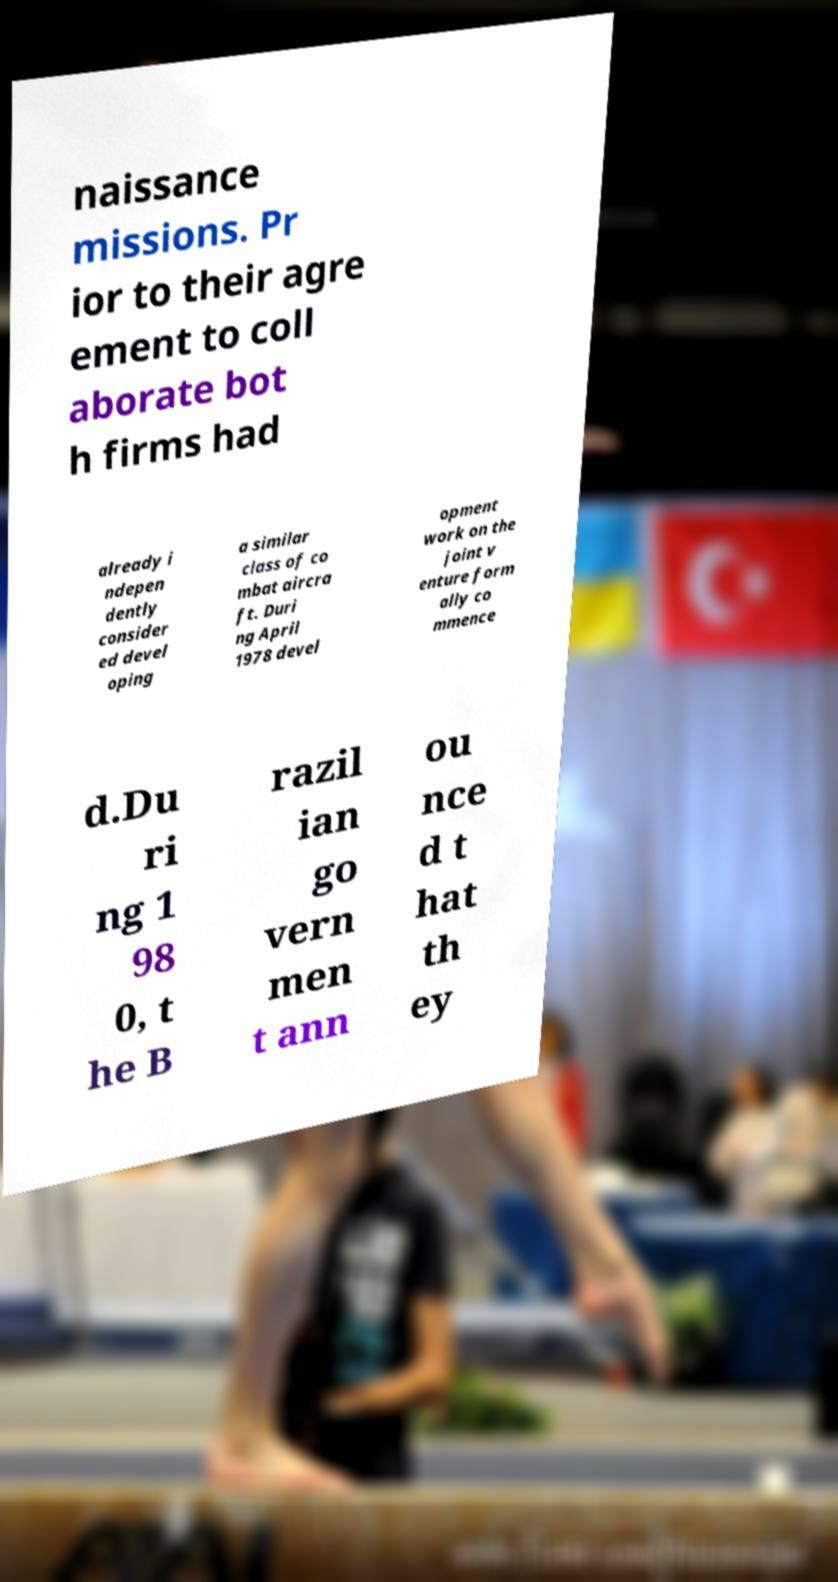For documentation purposes, I need the text within this image transcribed. Could you provide that? naissance missions. Pr ior to their agre ement to coll aborate bot h firms had already i ndepen dently consider ed devel oping a similar class of co mbat aircra ft. Duri ng April 1978 devel opment work on the joint v enture form ally co mmence d.Du ri ng 1 98 0, t he B razil ian go vern men t ann ou nce d t hat th ey 